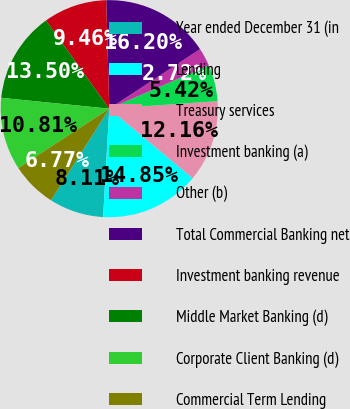Convert chart. <chart><loc_0><loc_0><loc_500><loc_500><pie_chart><fcel>Year ended December 31 (in<fcel>Lending<fcel>Treasury services<fcel>Investment banking (a)<fcel>Other (b)<fcel>Total Commercial Banking net<fcel>Investment banking revenue<fcel>Middle Market Banking (d)<fcel>Corporate Client Banking (d)<fcel>Commercial Term Lending<nl><fcel>8.11%<fcel>14.85%<fcel>12.16%<fcel>5.42%<fcel>2.72%<fcel>16.2%<fcel>9.46%<fcel>13.5%<fcel>10.81%<fcel>6.77%<nl></chart> 